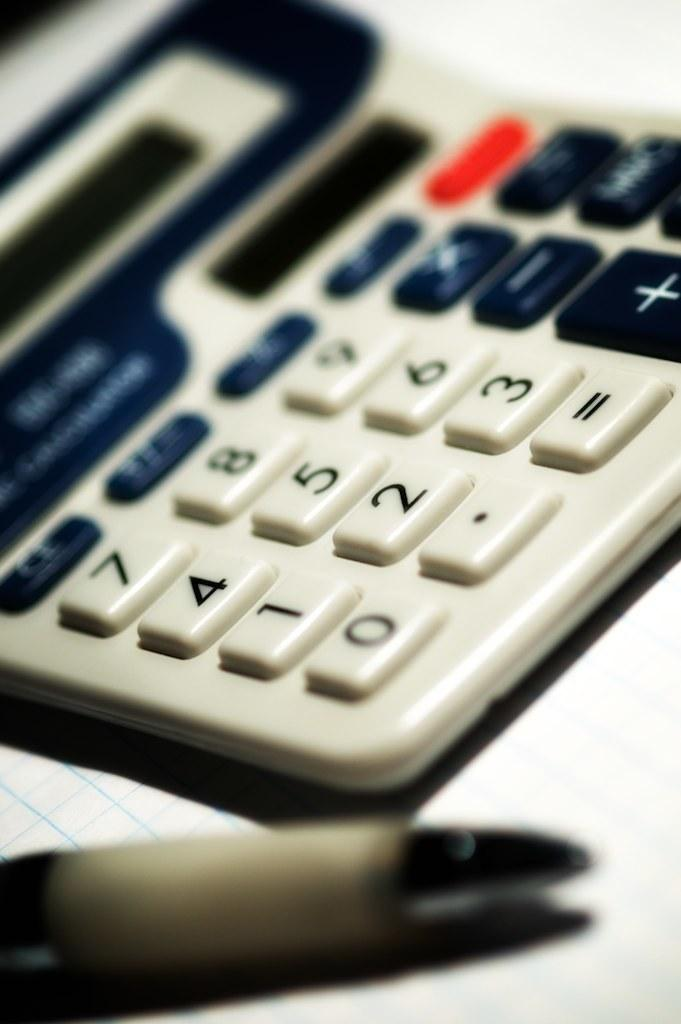<image>
Render a clear and concise summary of the photo. A calculator has numbers 0 through 9 on its buttons. 